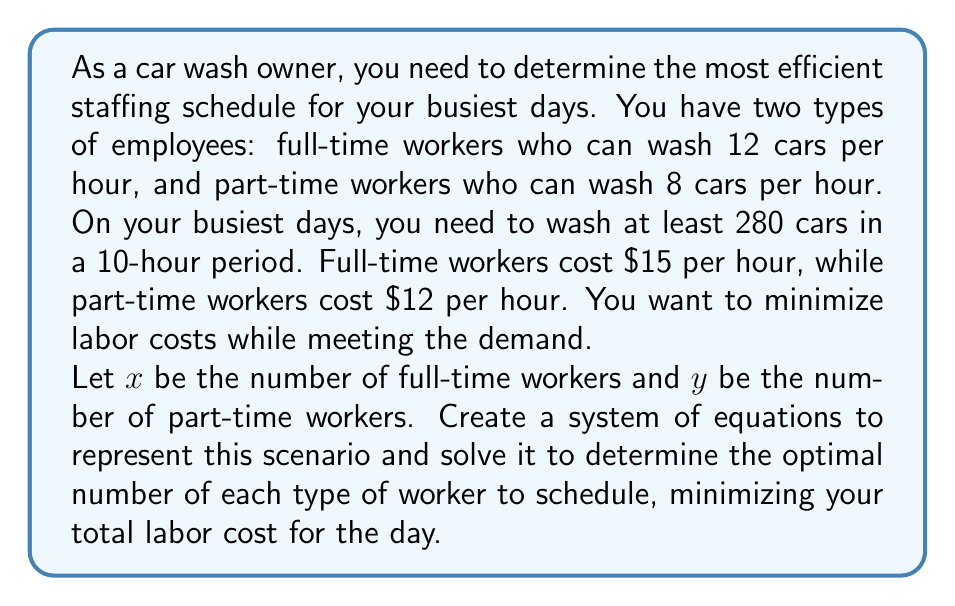Help me with this question. To solve this problem, we need to set up a system of equations based on the given information:

1. Capacity constraint:
   The total number of cars washed must be at least 280 in 10 hours.
   $$(12x + 8y) \cdot 10 \geq 280$$
   Simplifying: $120x + 80y \geq 280$

2. Cost function:
   We want to minimize the total labor cost for 10 hours.
   $$C = 10(15x + 12y)$$
   Where $C$ is the total cost.

Now, we need to find the minimum value of $C$ subject to the constraint $120x + 80y \geq 280$.

To solve this, we can use the method of linear programming:

1. Convert the inequality to an equation:
   $120x + 80y = 280$

2. Solve for $y$:
   $y = \frac{280 - 120x}{80} = 3.5 - 1.5x$

3. Substitute this into the cost function:
   $$C = 10(15x + 12(3.5 - 1.5x))$$
   $$C = 10(15x + 42 - 18x)$$
   $$C = 10(-3x + 42)$$
   $$C = -30x + 420$$

4. To minimize $C$, we need to maximize $x$, but $x$ must be a non-negative integer.

5. The maximum value of $x$ that satisfies the constraint is when $y = 0$:
   $120x = 280$
   $x = \frac{280}{120} = \frac{7}{3} \approx 2.33$

6. Since $x$ must be an integer, the optimal solution is $x = 2$ and $y = 1$:
   $120(2) + 80(1) = 320 \geq 280$

Therefore, the optimal staffing is 2 full-time workers and 1 part-time worker.
Answer: The optimal staffing schedule is 2 full-time workers and 1 part-time worker, resulting in a total labor cost of $420 for the 10-hour period. 